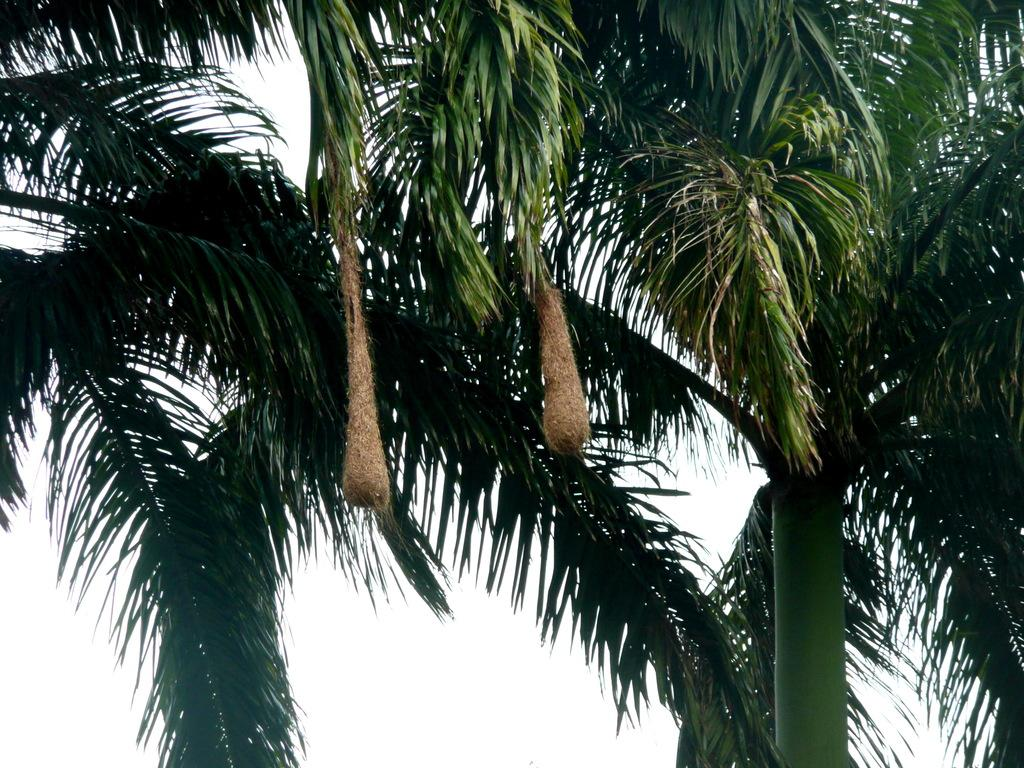What type of vegetation can be seen in the image? There are trees in the image. What is visible in the background of the image? The sky is visible in the image. What can be observed in the sky? Clouds are present in the sky. What type of paint is being used to create the clouds in the image? There is no paint present in the image, as the clouds are a natural part of the sky. 